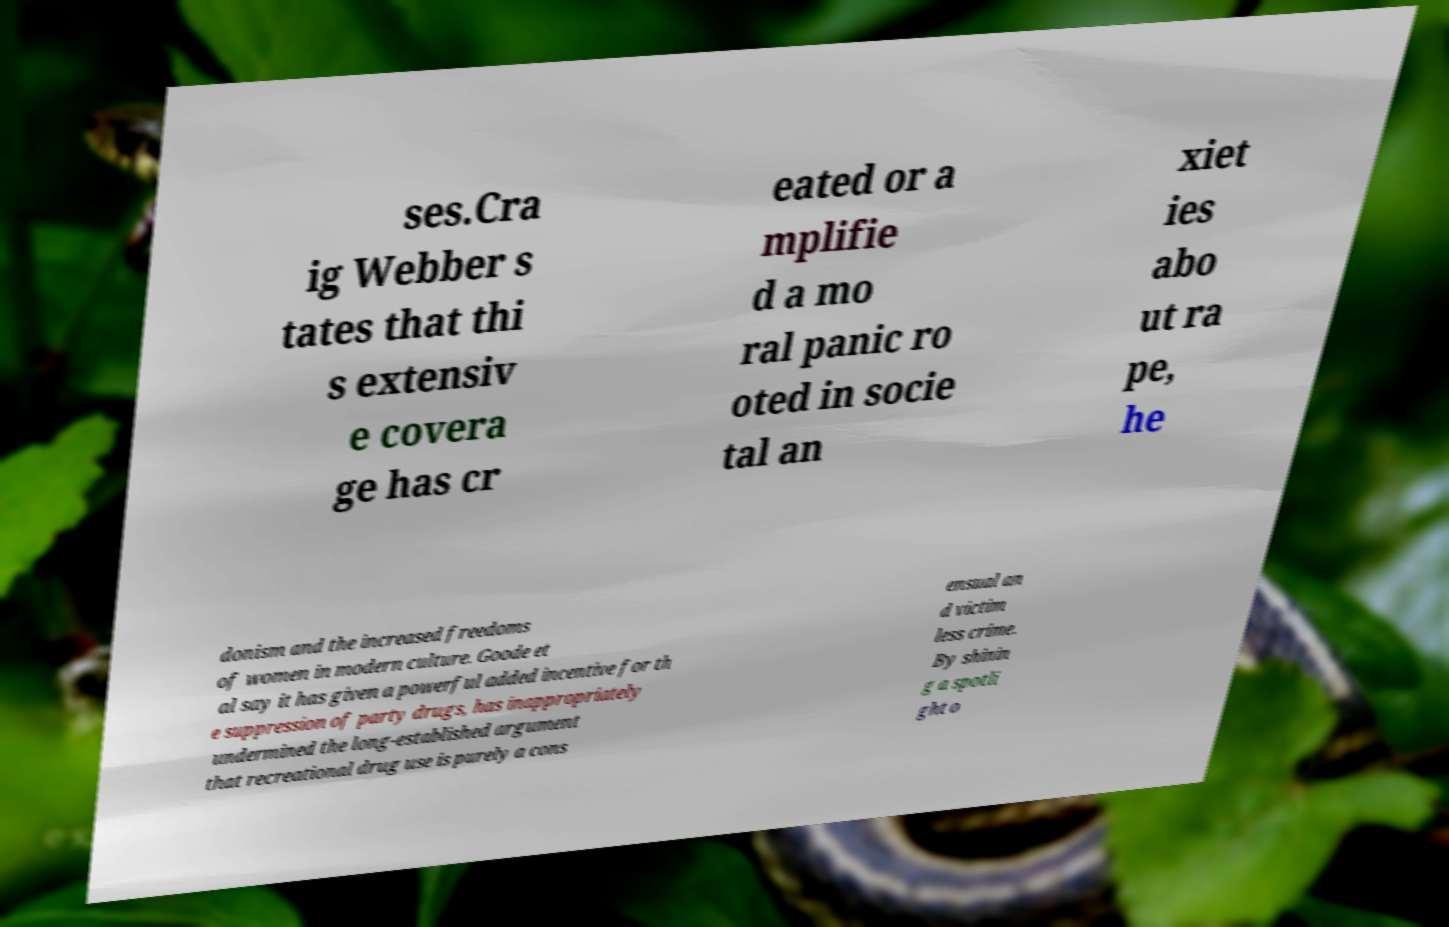I need the written content from this picture converted into text. Can you do that? ses.Cra ig Webber s tates that thi s extensiv e covera ge has cr eated or a mplifie d a mo ral panic ro oted in socie tal an xiet ies abo ut ra pe, he donism and the increased freedoms of women in modern culture. Goode et al say it has given a powerful added incentive for th e suppression of party drugs, has inappropriately undermined the long-established argument that recreational drug use is purely a cons ensual an d victim less crime. By shinin g a spotli ght o 